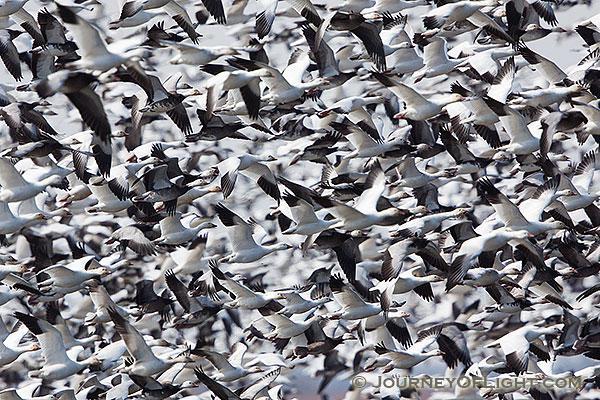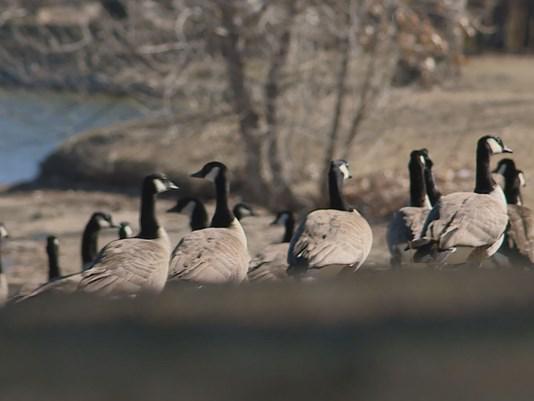The first image is the image on the left, the second image is the image on the right. Evaluate the accuracy of this statement regarding the images: "In one image, white ducks and geese are congregated on a green grassy field.". Is it true? Answer yes or no. No. The first image is the image on the left, the second image is the image on the right. Analyze the images presented: Is the assertion "There is water in the image on the left." valid? Answer yes or no. No. 